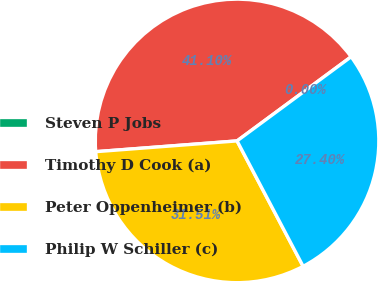Convert chart to OTSL. <chart><loc_0><loc_0><loc_500><loc_500><pie_chart><fcel>Steven P Jobs<fcel>Timothy D Cook (a)<fcel>Peter Oppenheimer (b)<fcel>Philip W Schiller (c)<nl><fcel>0.0%<fcel>41.1%<fcel>31.51%<fcel>27.4%<nl></chart> 